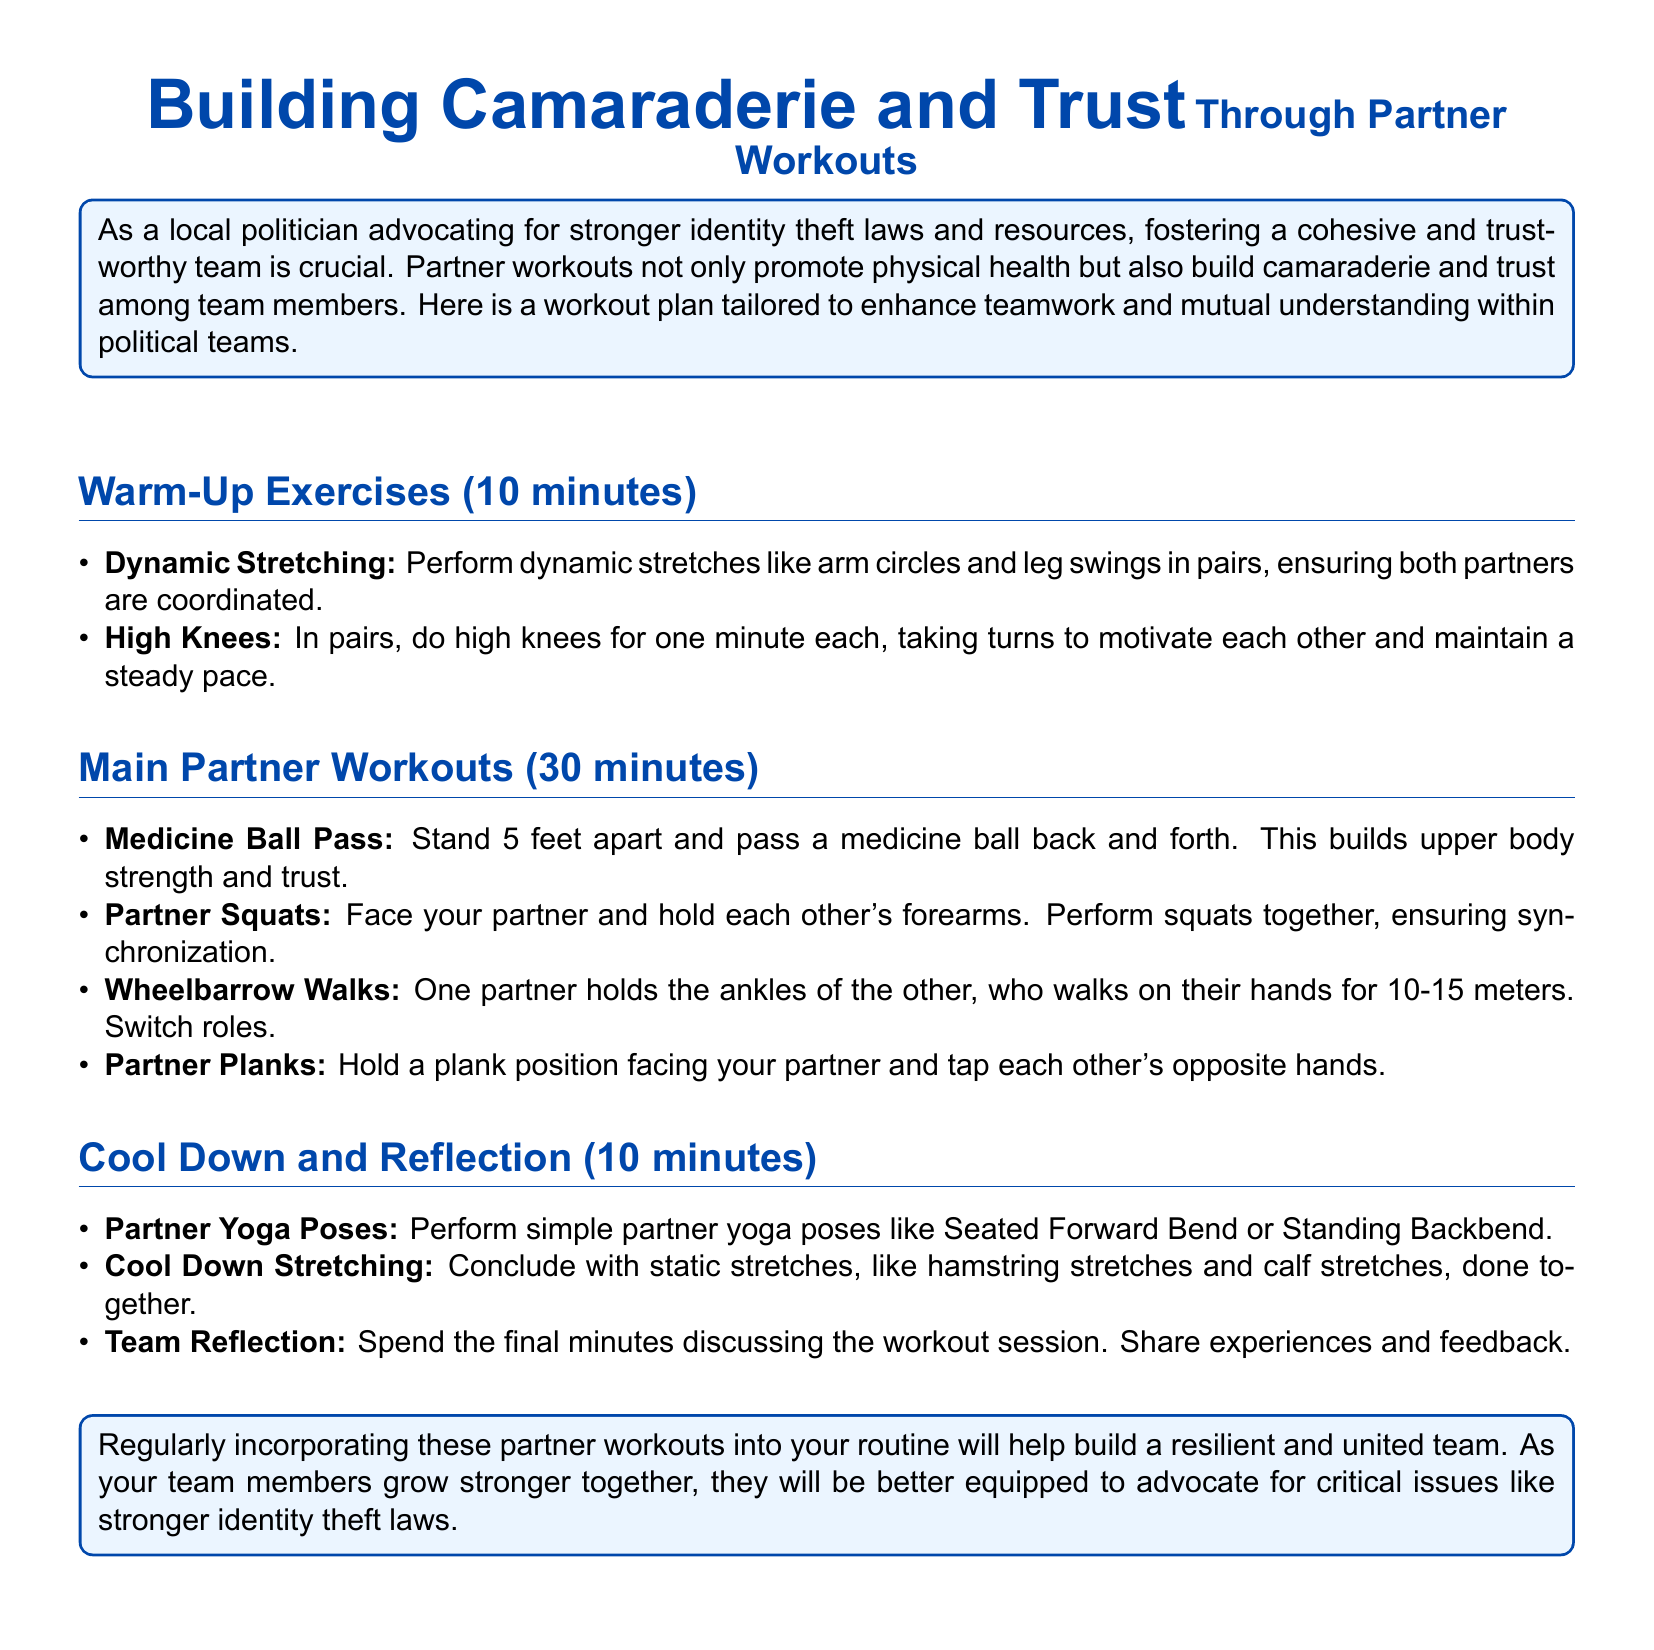What is the total time for the workout plan? The total time includes warm-up, partner workouts, and cool down, summing to 10 + 30 + 10 minutes = 50 minutes.
Answer: 50 minutes How many main partner workouts are listed? The document details the main partner workouts section, where 4 workouts are specified.
Answer: 4 workouts What is the first warm-up exercise? The first warm-up exercise is named in the list of warm-up exercises, which is dynamic stretching.
Answer: Dynamic Stretching What do partners do during the Medicine Ball Pass? In the Medicine Ball Pass activity, partners stand 5 feet apart and pass a medicine ball back and forth.
Answer: Pass a medicine ball What is the purpose of the Team Reflection? The team reflection is meant for members to discuss the workout session and share experiences.
Answer: Discuss the workout session How long should the cool down last? The document specifies that the cool down should take 10 minutes.
Answer: 10 minutes What is the last main partner workout mentioned? The last main partner workout listed is Partner Planks.
Answer: Partner Planks What type of stretching is performed at the end of the workout? The document mentions static stretches as the type of stretching performed during cool down.
Answer: Static stretches 